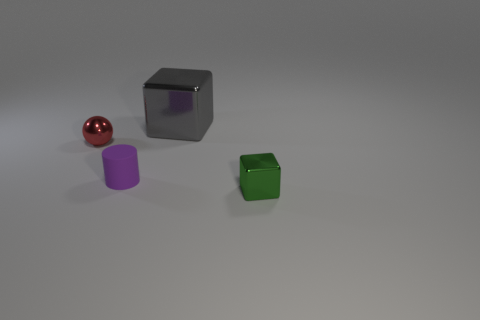Add 1 green metal things. How many objects exist? 5 Subtract all cylinders. How many objects are left? 3 Add 4 small purple things. How many small purple things are left? 5 Add 2 tiny blue cylinders. How many tiny blue cylinders exist? 2 Subtract 1 green blocks. How many objects are left? 3 Subtract all tiny purple metal spheres. Subtract all red spheres. How many objects are left? 3 